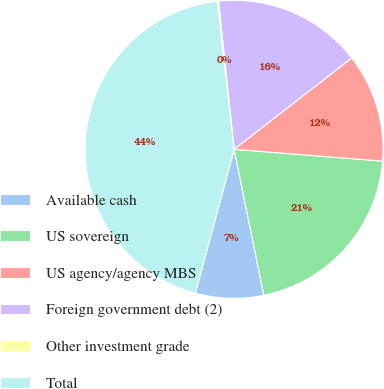Convert chart. <chart><loc_0><loc_0><loc_500><loc_500><pie_chart><fcel>Available cash<fcel>US sovereign<fcel>US agency/agency MBS<fcel>Foreign government debt (2)<fcel>Other investment grade<fcel>Total<nl><fcel>7.39%<fcel>20.54%<fcel>11.77%<fcel>16.16%<fcel>0.14%<fcel>44.0%<nl></chart> 